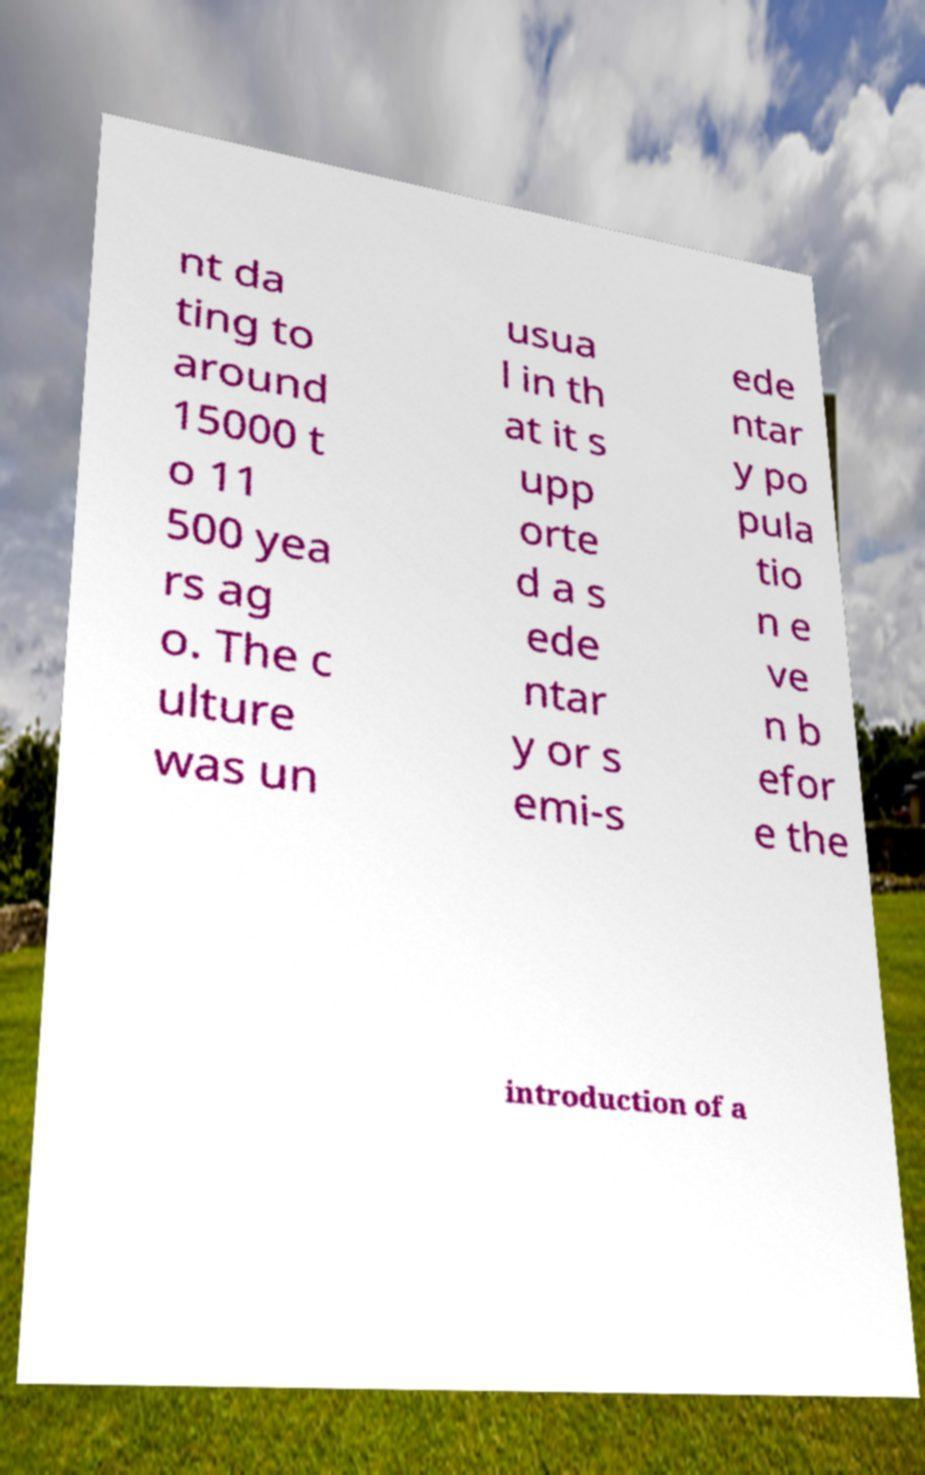Please identify and transcribe the text found in this image. nt da ting to around 15000 t o 11 500 yea rs ag o. The c ulture was un usua l in th at it s upp orte d a s ede ntar y or s emi-s ede ntar y po pula tio n e ve n b efor e the introduction of a 